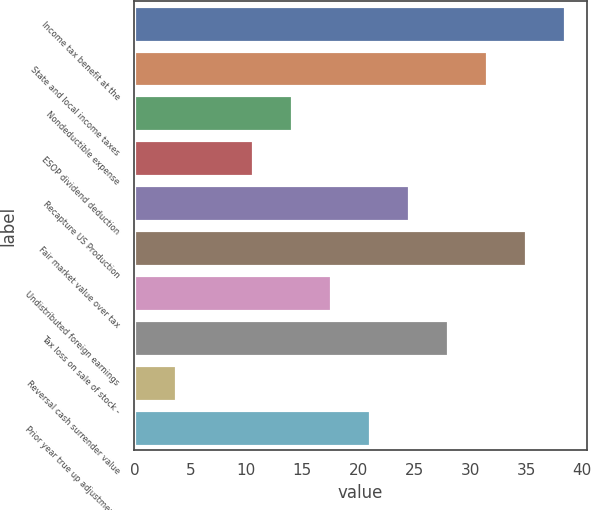Convert chart to OTSL. <chart><loc_0><loc_0><loc_500><loc_500><bar_chart><fcel>Income tax benefit at the<fcel>State and local income taxes<fcel>Nondeductible expense<fcel>ESOP dividend deduction<fcel>Recapture US Production<fcel>Fair market value over tax<fcel>Undistributed foreign earnings<fcel>Tax loss on sale of stock -<fcel>Reversal cash surrender value<fcel>Prior year true up adjustments<nl><fcel>38.48<fcel>31.52<fcel>14.12<fcel>10.64<fcel>24.56<fcel>35<fcel>17.6<fcel>28.04<fcel>3.68<fcel>21.08<nl></chart> 